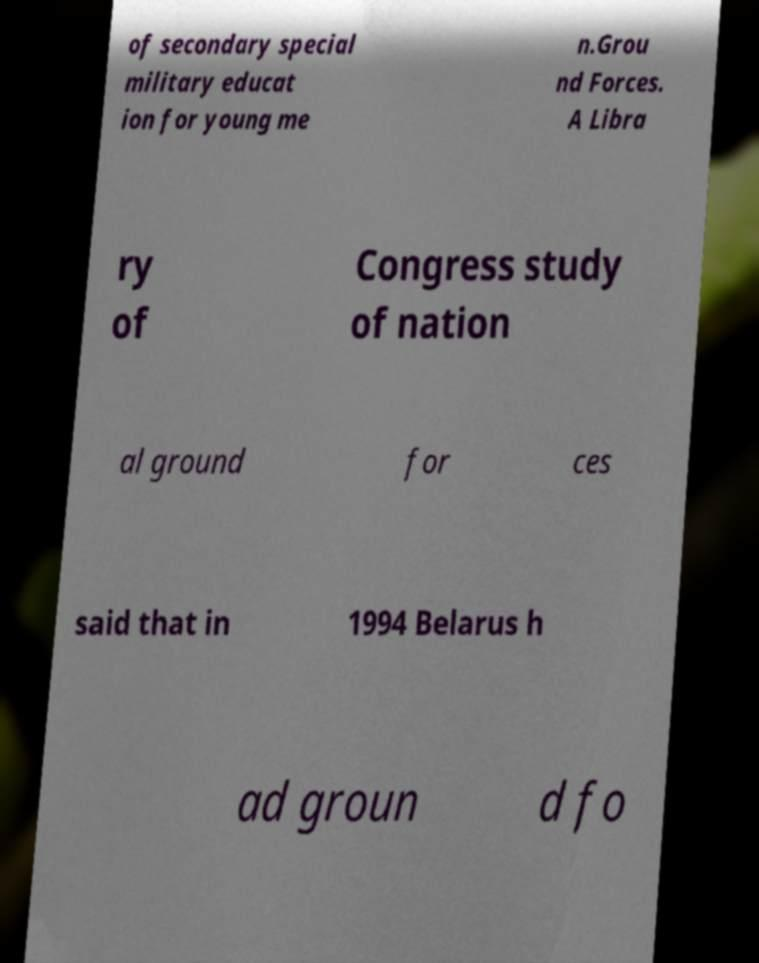I need the written content from this picture converted into text. Can you do that? of secondary special military educat ion for young me n.Grou nd Forces. A Libra ry of Congress study of nation al ground for ces said that in 1994 Belarus h ad groun d fo 